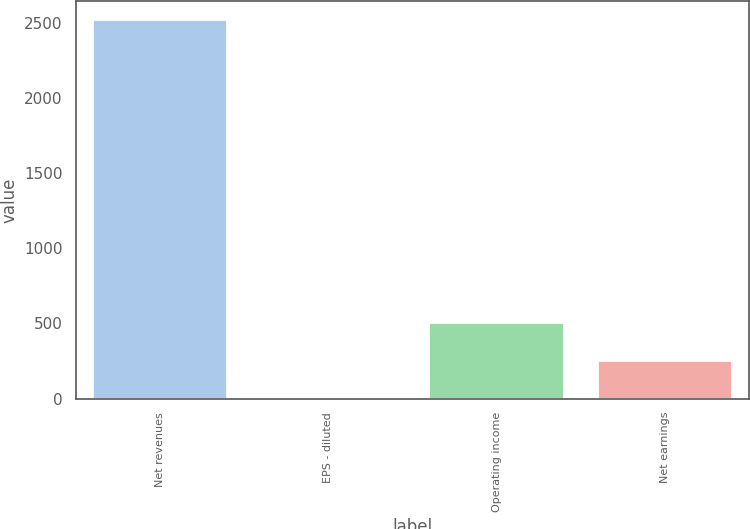Convert chart. <chart><loc_0><loc_0><loc_500><loc_500><bar_chart><fcel>Net revenues<fcel>EPS - diluted<fcel>Operating income<fcel>Net earnings<nl><fcel>2515.4<fcel>0.01<fcel>503.09<fcel>251.55<nl></chart> 